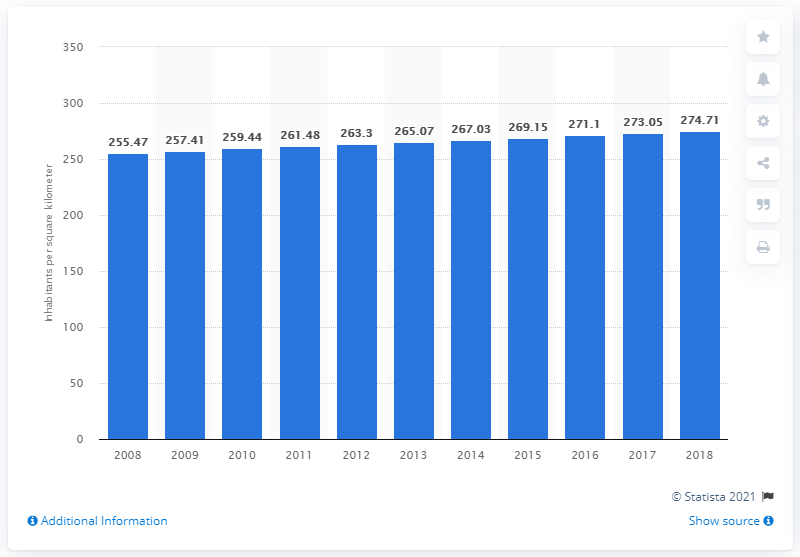Highlight a few significant elements in this photo. In 2018, the population density in the UK was approximately 274.71 people per square kilometer. 